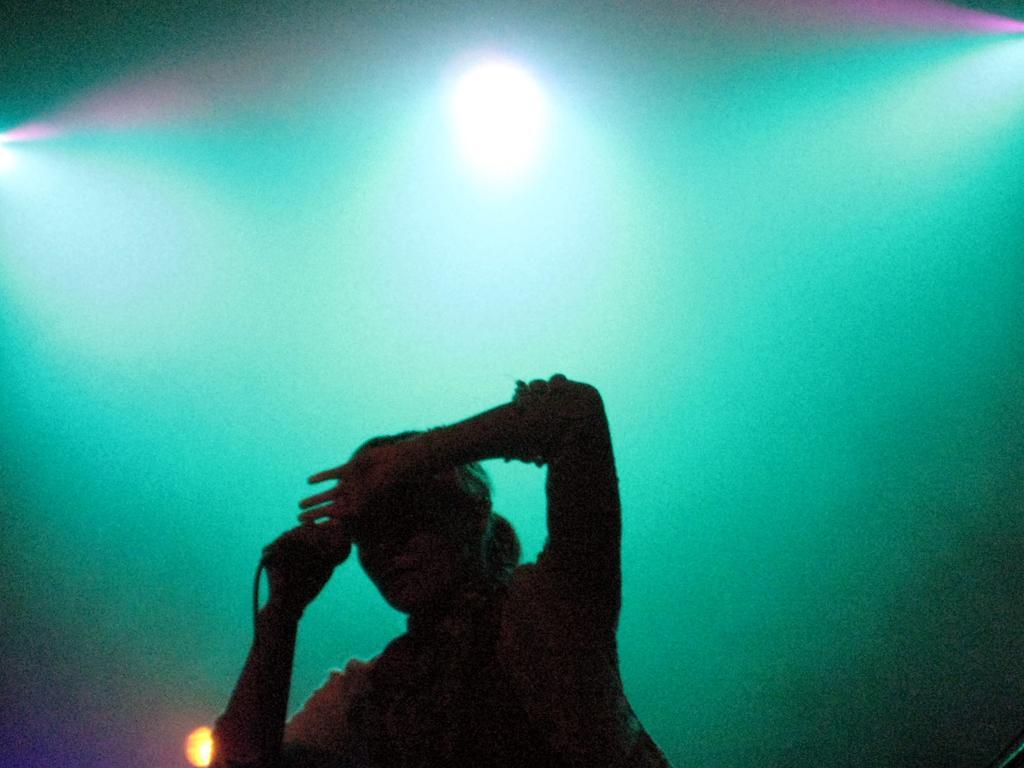Describe this image in one or two sentences. In this image, we can see a human is holding a microphone with wire. Background we can see the lights. 